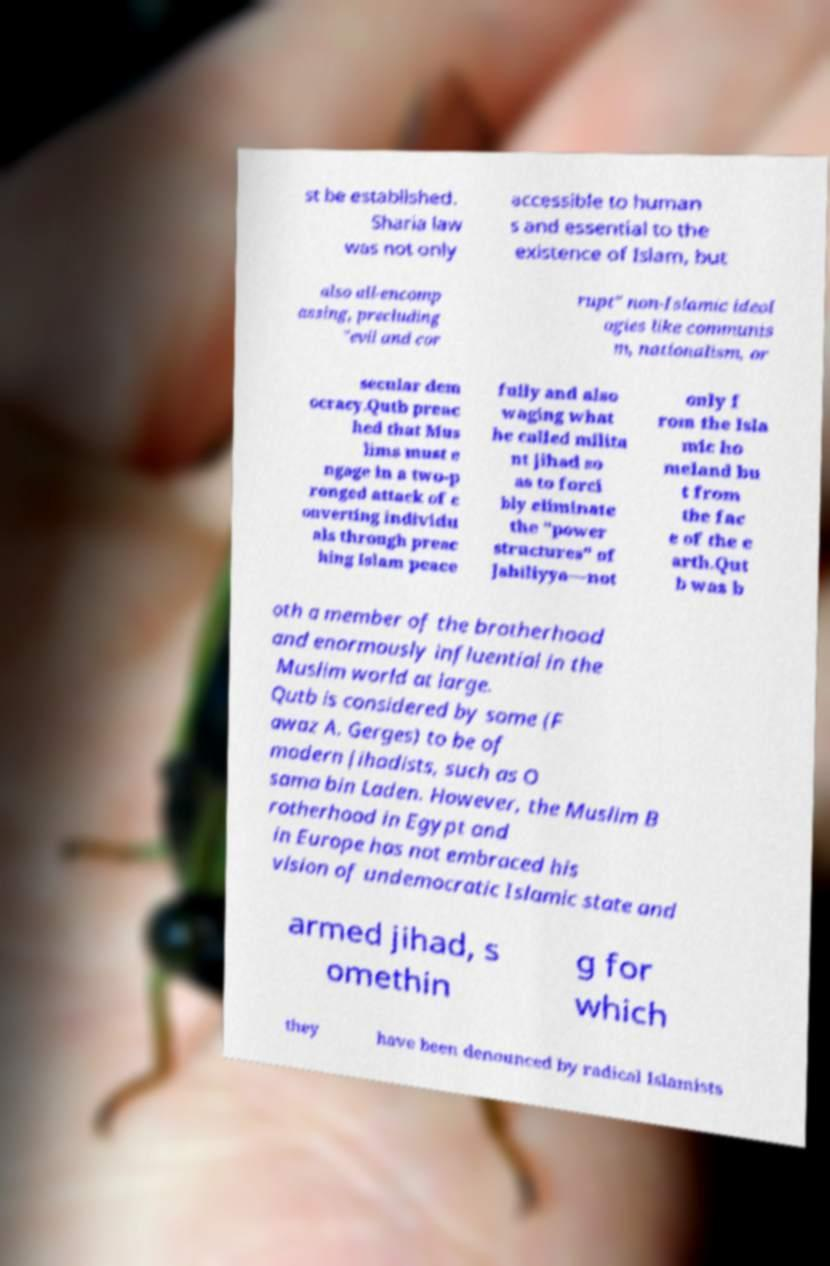Please identify and transcribe the text found in this image. st be established. Sharia law was not only accessible to human s and essential to the existence of Islam, but also all-encomp assing, precluding "evil and cor rupt" non-Islamic ideol ogies like communis m, nationalism, or secular dem ocracy.Qutb preac hed that Mus lims must e ngage in a two-p ronged attack of c onverting individu als through preac hing Islam peace fully and also waging what he called milita nt jihad so as to forci bly eliminate the "power structures" of Jahiliyya—not only f rom the Isla mic ho meland bu t from the fac e of the e arth.Qut b was b oth a member of the brotherhood and enormously influential in the Muslim world at large. Qutb is considered by some (F awaz A. Gerges) to be of modern jihadists, such as O sama bin Laden. However, the Muslim B rotherhood in Egypt and in Europe has not embraced his vision of undemocratic Islamic state and armed jihad, s omethin g for which they have been denounced by radical Islamists 